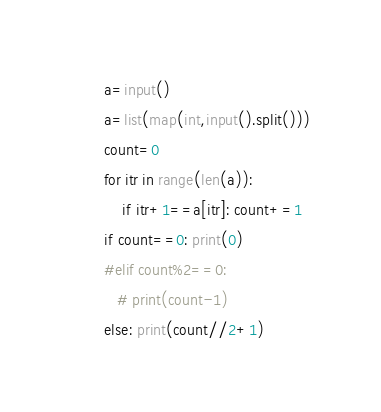Convert code to text. <code><loc_0><loc_0><loc_500><loc_500><_Python_>a=input()
a=list(map(int,input().split()))
count=0
for itr in range(len(a)):
    if itr+1==a[itr]: count+=1
if count==0: print(0)
#elif count%2==0:
   # print(count-1)
else: print(count//2+1)</code> 